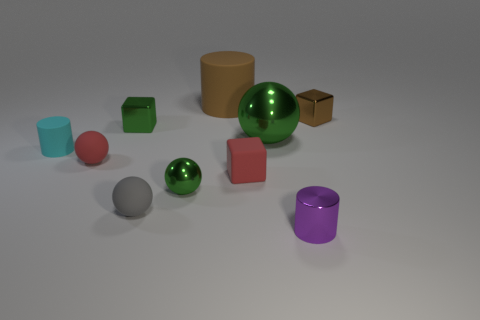Subtract all red cubes. Subtract all red balls. How many cubes are left? 2 Subtract all blue cylinders. How many green spheres are left? 2 Subtract all metallic blocks. Subtract all small blue metallic things. How many objects are left? 8 Add 7 small purple metallic things. How many small purple metallic things are left? 8 Add 7 tiny red spheres. How many tiny red spheres exist? 8 Subtract all brown cylinders. How many cylinders are left? 2 Subtract all large green balls. How many balls are left? 3 Subtract 1 gray spheres. How many objects are left? 9 Subtract all cylinders. How many objects are left? 7 Subtract 1 cubes. How many cubes are left? 2 